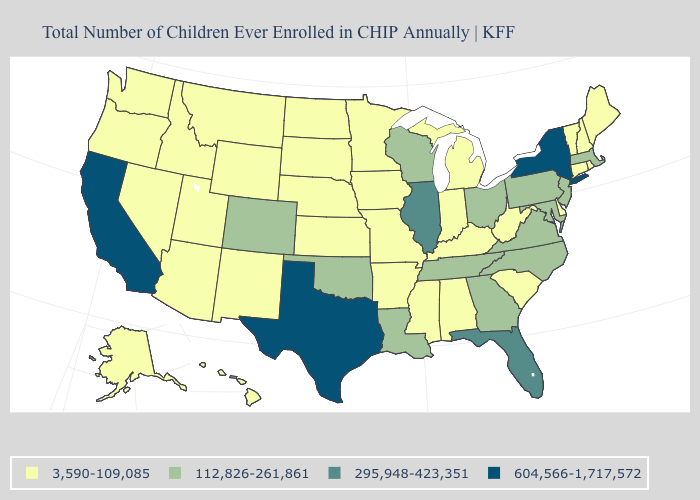Name the states that have a value in the range 3,590-109,085?
Be succinct. Alabama, Alaska, Arizona, Arkansas, Connecticut, Delaware, Hawaii, Idaho, Indiana, Iowa, Kansas, Kentucky, Maine, Michigan, Minnesota, Mississippi, Missouri, Montana, Nebraska, Nevada, New Hampshire, New Mexico, North Dakota, Oregon, Rhode Island, South Carolina, South Dakota, Utah, Vermont, Washington, West Virginia, Wyoming. What is the value of New Hampshire?
Answer briefly. 3,590-109,085. Name the states that have a value in the range 112,826-261,861?
Keep it brief. Colorado, Georgia, Louisiana, Maryland, Massachusetts, New Jersey, North Carolina, Ohio, Oklahoma, Pennsylvania, Tennessee, Virginia, Wisconsin. How many symbols are there in the legend?
Quick response, please. 4. What is the highest value in the USA?
Short answer required. 604,566-1,717,572. Name the states that have a value in the range 295,948-423,351?
Write a very short answer. Florida, Illinois. What is the value of Oregon?
Be succinct. 3,590-109,085. How many symbols are there in the legend?
Concise answer only. 4. Name the states that have a value in the range 3,590-109,085?
Short answer required. Alabama, Alaska, Arizona, Arkansas, Connecticut, Delaware, Hawaii, Idaho, Indiana, Iowa, Kansas, Kentucky, Maine, Michigan, Minnesota, Mississippi, Missouri, Montana, Nebraska, Nevada, New Hampshire, New Mexico, North Dakota, Oregon, Rhode Island, South Carolina, South Dakota, Utah, Vermont, Washington, West Virginia, Wyoming. Among the states that border Rhode Island , which have the highest value?
Write a very short answer. Massachusetts. Does Alaska have the highest value in the USA?
Keep it brief. No. What is the lowest value in the West?
Write a very short answer. 3,590-109,085. Does the map have missing data?
Quick response, please. No. How many symbols are there in the legend?
Be succinct. 4. Does California have the highest value in the USA?
Give a very brief answer. Yes. 